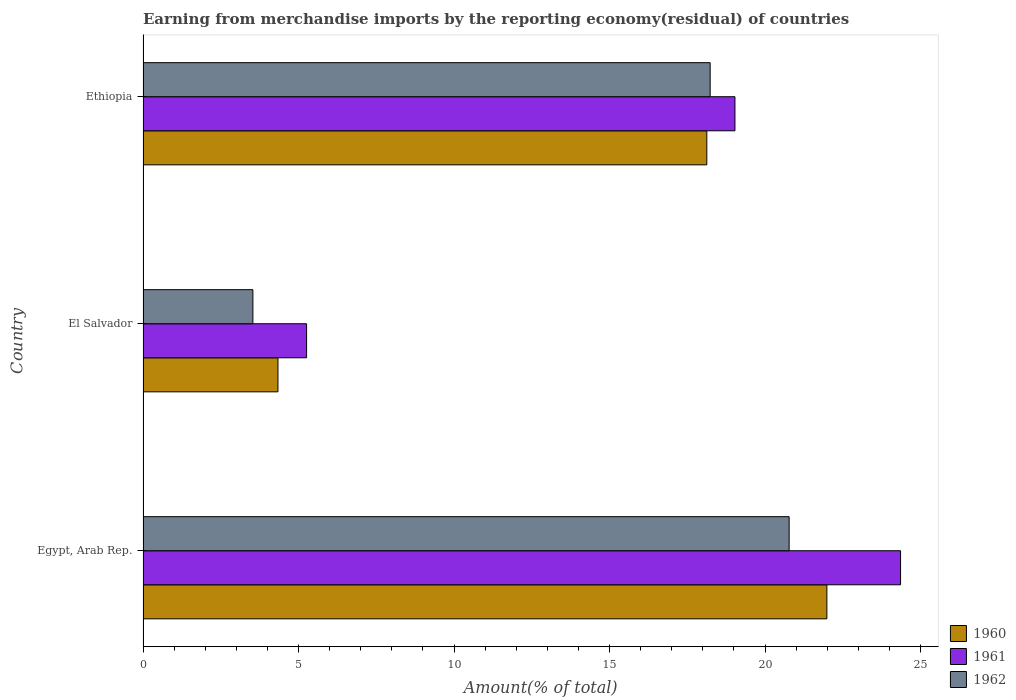Are the number of bars per tick equal to the number of legend labels?
Provide a succinct answer. Yes. Are the number of bars on each tick of the Y-axis equal?
Make the answer very short. Yes. How many bars are there on the 1st tick from the top?
Your response must be concise. 3. How many bars are there on the 3rd tick from the bottom?
Ensure brevity in your answer.  3. What is the label of the 3rd group of bars from the top?
Provide a succinct answer. Egypt, Arab Rep. What is the percentage of amount earned from merchandise imports in 1962 in Ethiopia?
Keep it short and to the point. 18.23. Across all countries, what is the maximum percentage of amount earned from merchandise imports in 1960?
Provide a short and direct response. 21.99. Across all countries, what is the minimum percentage of amount earned from merchandise imports in 1960?
Ensure brevity in your answer.  4.34. In which country was the percentage of amount earned from merchandise imports in 1961 maximum?
Keep it short and to the point. Egypt, Arab Rep. In which country was the percentage of amount earned from merchandise imports in 1962 minimum?
Make the answer very short. El Salvador. What is the total percentage of amount earned from merchandise imports in 1960 in the graph?
Give a very brief answer. 44.45. What is the difference between the percentage of amount earned from merchandise imports in 1962 in El Salvador and that in Ethiopia?
Ensure brevity in your answer.  -14.7. What is the difference between the percentage of amount earned from merchandise imports in 1961 in El Salvador and the percentage of amount earned from merchandise imports in 1962 in Egypt, Arab Rep.?
Offer a terse response. -15.52. What is the average percentage of amount earned from merchandise imports in 1961 per country?
Your answer should be compact. 16.22. What is the difference between the percentage of amount earned from merchandise imports in 1960 and percentage of amount earned from merchandise imports in 1962 in El Salvador?
Provide a succinct answer. 0.81. What is the ratio of the percentage of amount earned from merchandise imports in 1961 in El Salvador to that in Ethiopia?
Make the answer very short. 0.28. Is the percentage of amount earned from merchandise imports in 1962 in El Salvador less than that in Ethiopia?
Give a very brief answer. Yes. Is the difference between the percentage of amount earned from merchandise imports in 1960 in Egypt, Arab Rep. and El Salvador greater than the difference between the percentage of amount earned from merchandise imports in 1962 in Egypt, Arab Rep. and El Salvador?
Provide a succinct answer. Yes. What is the difference between the highest and the second highest percentage of amount earned from merchandise imports in 1960?
Your answer should be compact. 3.86. What is the difference between the highest and the lowest percentage of amount earned from merchandise imports in 1961?
Make the answer very short. 19.1. Is the sum of the percentage of amount earned from merchandise imports in 1961 in Egypt, Arab Rep. and El Salvador greater than the maximum percentage of amount earned from merchandise imports in 1962 across all countries?
Offer a very short reply. Yes. What does the 2nd bar from the top in Ethiopia represents?
Give a very brief answer. 1961. What does the 3rd bar from the bottom in Egypt, Arab Rep. represents?
Offer a terse response. 1962. Is it the case that in every country, the sum of the percentage of amount earned from merchandise imports in 1960 and percentage of amount earned from merchandise imports in 1961 is greater than the percentage of amount earned from merchandise imports in 1962?
Keep it short and to the point. Yes. Are all the bars in the graph horizontal?
Provide a short and direct response. Yes. How many countries are there in the graph?
Provide a succinct answer. 3. Does the graph contain any zero values?
Offer a terse response. No. What is the title of the graph?
Keep it short and to the point. Earning from merchandise imports by the reporting economy(residual) of countries. Does "2006" appear as one of the legend labels in the graph?
Keep it short and to the point. No. What is the label or title of the X-axis?
Make the answer very short. Amount(% of total). What is the Amount(% of total) in 1960 in Egypt, Arab Rep.?
Your response must be concise. 21.99. What is the Amount(% of total) of 1961 in Egypt, Arab Rep.?
Your response must be concise. 24.36. What is the Amount(% of total) in 1962 in Egypt, Arab Rep.?
Offer a very short reply. 20.77. What is the Amount(% of total) in 1960 in El Salvador?
Ensure brevity in your answer.  4.34. What is the Amount(% of total) in 1961 in El Salvador?
Your response must be concise. 5.26. What is the Amount(% of total) of 1962 in El Salvador?
Keep it short and to the point. 3.53. What is the Amount(% of total) in 1960 in Ethiopia?
Your answer should be very brief. 18.13. What is the Amount(% of total) of 1961 in Ethiopia?
Give a very brief answer. 19.03. What is the Amount(% of total) in 1962 in Ethiopia?
Ensure brevity in your answer.  18.23. Across all countries, what is the maximum Amount(% of total) in 1960?
Provide a short and direct response. 21.99. Across all countries, what is the maximum Amount(% of total) of 1961?
Ensure brevity in your answer.  24.36. Across all countries, what is the maximum Amount(% of total) in 1962?
Ensure brevity in your answer.  20.77. Across all countries, what is the minimum Amount(% of total) of 1960?
Make the answer very short. 4.34. Across all countries, what is the minimum Amount(% of total) in 1961?
Your answer should be compact. 5.26. Across all countries, what is the minimum Amount(% of total) in 1962?
Keep it short and to the point. 3.53. What is the total Amount(% of total) of 1960 in the graph?
Give a very brief answer. 44.45. What is the total Amount(% of total) in 1961 in the graph?
Ensure brevity in your answer.  48.65. What is the total Amount(% of total) of 1962 in the graph?
Offer a terse response. 42.54. What is the difference between the Amount(% of total) in 1960 in Egypt, Arab Rep. and that in El Salvador?
Give a very brief answer. 17.65. What is the difference between the Amount(% of total) in 1961 in Egypt, Arab Rep. and that in El Salvador?
Make the answer very short. 19.1. What is the difference between the Amount(% of total) in 1962 in Egypt, Arab Rep. and that in El Salvador?
Your response must be concise. 17.24. What is the difference between the Amount(% of total) in 1960 in Egypt, Arab Rep. and that in Ethiopia?
Provide a succinct answer. 3.86. What is the difference between the Amount(% of total) of 1961 in Egypt, Arab Rep. and that in Ethiopia?
Give a very brief answer. 5.32. What is the difference between the Amount(% of total) in 1962 in Egypt, Arab Rep. and that in Ethiopia?
Make the answer very short. 2.54. What is the difference between the Amount(% of total) of 1960 in El Salvador and that in Ethiopia?
Ensure brevity in your answer.  -13.79. What is the difference between the Amount(% of total) in 1961 in El Salvador and that in Ethiopia?
Provide a succinct answer. -13.77. What is the difference between the Amount(% of total) in 1962 in El Salvador and that in Ethiopia?
Offer a terse response. -14.7. What is the difference between the Amount(% of total) in 1960 in Egypt, Arab Rep. and the Amount(% of total) in 1961 in El Salvador?
Offer a terse response. 16.73. What is the difference between the Amount(% of total) of 1960 in Egypt, Arab Rep. and the Amount(% of total) of 1962 in El Salvador?
Offer a very short reply. 18.46. What is the difference between the Amount(% of total) in 1961 in Egypt, Arab Rep. and the Amount(% of total) in 1962 in El Salvador?
Provide a succinct answer. 20.83. What is the difference between the Amount(% of total) in 1960 in Egypt, Arab Rep. and the Amount(% of total) in 1961 in Ethiopia?
Provide a short and direct response. 2.96. What is the difference between the Amount(% of total) in 1960 in Egypt, Arab Rep. and the Amount(% of total) in 1962 in Ethiopia?
Keep it short and to the point. 3.75. What is the difference between the Amount(% of total) in 1961 in Egypt, Arab Rep. and the Amount(% of total) in 1962 in Ethiopia?
Your answer should be very brief. 6.12. What is the difference between the Amount(% of total) of 1960 in El Salvador and the Amount(% of total) of 1961 in Ethiopia?
Your answer should be compact. -14.7. What is the difference between the Amount(% of total) in 1960 in El Salvador and the Amount(% of total) in 1962 in Ethiopia?
Provide a short and direct response. -13.9. What is the difference between the Amount(% of total) of 1961 in El Salvador and the Amount(% of total) of 1962 in Ethiopia?
Ensure brevity in your answer.  -12.98. What is the average Amount(% of total) of 1960 per country?
Ensure brevity in your answer.  14.82. What is the average Amount(% of total) of 1961 per country?
Your response must be concise. 16.22. What is the average Amount(% of total) in 1962 per country?
Make the answer very short. 14.18. What is the difference between the Amount(% of total) in 1960 and Amount(% of total) in 1961 in Egypt, Arab Rep.?
Keep it short and to the point. -2.37. What is the difference between the Amount(% of total) of 1960 and Amount(% of total) of 1962 in Egypt, Arab Rep.?
Your answer should be compact. 1.21. What is the difference between the Amount(% of total) of 1961 and Amount(% of total) of 1962 in Egypt, Arab Rep.?
Provide a short and direct response. 3.58. What is the difference between the Amount(% of total) of 1960 and Amount(% of total) of 1961 in El Salvador?
Provide a succinct answer. -0.92. What is the difference between the Amount(% of total) in 1960 and Amount(% of total) in 1962 in El Salvador?
Give a very brief answer. 0.81. What is the difference between the Amount(% of total) in 1961 and Amount(% of total) in 1962 in El Salvador?
Keep it short and to the point. 1.73. What is the difference between the Amount(% of total) in 1960 and Amount(% of total) in 1961 in Ethiopia?
Make the answer very short. -0.91. What is the difference between the Amount(% of total) of 1960 and Amount(% of total) of 1962 in Ethiopia?
Your answer should be compact. -0.11. What is the difference between the Amount(% of total) in 1961 and Amount(% of total) in 1962 in Ethiopia?
Offer a terse response. 0.8. What is the ratio of the Amount(% of total) of 1960 in Egypt, Arab Rep. to that in El Salvador?
Give a very brief answer. 5.07. What is the ratio of the Amount(% of total) in 1961 in Egypt, Arab Rep. to that in El Salvador?
Offer a terse response. 4.63. What is the ratio of the Amount(% of total) of 1962 in Egypt, Arab Rep. to that in El Salvador?
Your answer should be very brief. 5.88. What is the ratio of the Amount(% of total) of 1960 in Egypt, Arab Rep. to that in Ethiopia?
Your answer should be compact. 1.21. What is the ratio of the Amount(% of total) in 1961 in Egypt, Arab Rep. to that in Ethiopia?
Provide a short and direct response. 1.28. What is the ratio of the Amount(% of total) of 1962 in Egypt, Arab Rep. to that in Ethiopia?
Your answer should be compact. 1.14. What is the ratio of the Amount(% of total) of 1960 in El Salvador to that in Ethiopia?
Your response must be concise. 0.24. What is the ratio of the Amount(% of total) in 1961 in El Salvador to that in Ethiopia?
Give a very brief answer. 0.28. What is the ratio of the Amount(% of total) of 1962 in El Salvador to that in Ethiopia?
Offer a very short reply. 0.19. What is the difference between the highest and the second highest Amount(% of total) in 1960?
Ensure brevity in your answer.  3.86. What is the difference between the highest and the second highest Amount(% of total) in 1961?
Provide a succinct answer. 5.32. What is the difference between the highest and the second highest Amount(% of total) in 1962?
Provide a succinct answer. 2.54. What is the difference between the highest and the lowest Amount(% of total) in 1960?
Your answer should be compact. 17.65. What is the difference between the highest and the lowest Amount(% of total) in 1961?
Provide a succinct answer. 19.1. What is the difference between the highest and the lowest Amount(% of total) of 1962?
Offer a very short reply. 17.24. 